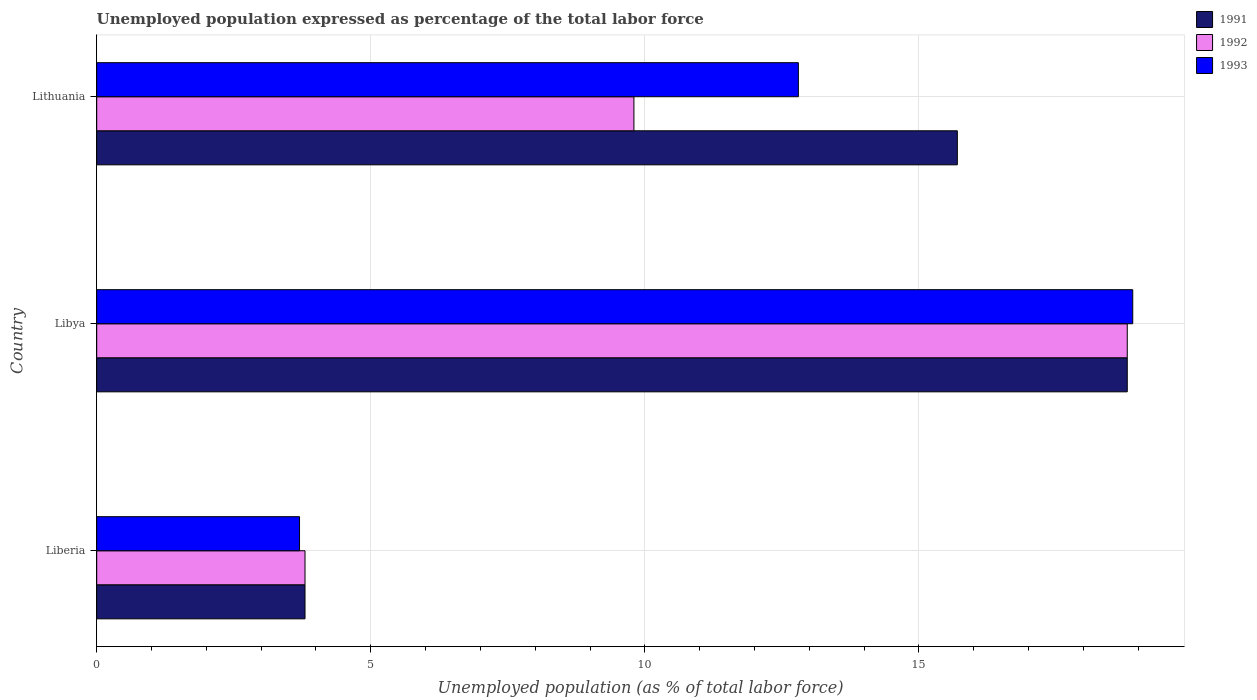How many different coloured bars are there?
Your answer should be compact. 3. Are the number of bars on each tick of the Y-axis equal?
Your response must be concise. Yes. What is the label of the 3rd group of bars from the top?
Your response must be concise. Liberia. What is the unemployment in in 1993 in Libya?
Provide a succinct answer. 18.9. Across all countries, what is the maximum unemployment in in 1991?
Your answer should be compact. 18.8. Across all countries, what is the minimum unemployment in in 1993?
Offer a terse response. 3.7. In which country was the unemployment in in 1993 maximum?
Your response must be concise. Libya. In which country was the unemployment in in 1993 minimum?
Give a very brief answer. Liberia. What is the total unemployment in in 1991 in the graph?
Your answer should be compact. 38.3. What is the difference between the unemployment in in 1993 in Liberia and that in Libya?
Offer a very short reply. -15.2. What is the difference between the unemployment in in 1991 in Lithuania and the unemployment in in 1992 in Libya?
Make the answer very short. -3.1. What is the average unemployment in in 1992 per country?
Your response must be concise. 10.8. In how many countries, is the unemployment in in 1992 greater than 14 %?
Your answer should be compact. 1. What is the ratio of the unemployment in in 1992 in Liberia to that in Libya?
Your answer should be compact. 0.2. Is the difference between the unemployment in in 1991 in Libya and Lithuania greater than the difference between the unemployment in in 1992 in Libya and Lithuania?
Your answer should be compact. No. What is the difference between the highest and the second highest unemployment in in 1993?
Keep it short and to the point. 6.1. What is the difference between the highest and the lowest unemployment in in 1991?
Your response must be concise. 15. What does the 3rd bar from the top in Lithuania represents?
Give a very brief answer. 1991. Does the graph contain any zero values?
Provide a short and direct response. No. How many legend labels are there?
Make the answer very short. 3. How are the legend labels stacked?
Offer a terse response. Vertical. What is the title of the graph?
Provide a succinct answer. Unemployed population expressed as percentage of the total labor force. What is the label or title of the X-axis?
Provide a succinct answer. Unemployed population (as % of total labor force). What is the Unemployed population (as % of total labor force) in 1991 in Liberia?
Keep it short and to the point. 3.8. What is the Unemployed population (as % of total labor force) in 1992 in Liberia?
Offer a very short reply. 3.8. What is the Unemployed population (as % of total labor force) in 1993 in Liberia?
Ensure brevity in your answer.  3.7. What is the Unemployed population (as % of total labor force) of 1991 in Libya?
Your answer should be very brief. 18.8. What is the Unemployed population (as % of total labor force) in 1992 in Libya?
Keep it short and to the point. 18.8. What is the Unemployed population (as % of total labor force) of 1993 in Libya?
Offer a very short reply. 18.9. What is the Unemployed population (as % of total labor force) in 1991 in Lithuania?
Your answer should be very brief. 15.7. What is the Unemployed population (as % of total labor force) in 1992 in Lithuania?
Keep it short and to the point. 9.8. What is the Unemployed population (as % of total labor force) in 1993 in Lithuania?
Offer a very short reply. 12.8. Across all countries, what is the maximum Unemployed population (as % of total labor force) in 1991?
Keep it short and to the point. 18.8. Across all countries, what is the maximum Unemployed population (as % of total labor force) in 1992?
Your answer should be very brief. 18.8. Across all countries, what is the maximum Unemployed population (as % of total labor force) in 1993?
Your answer should be compact. 18.9. Across all countries, what is the minimum Unemployed population (as % of total labor force) in 1991?
Ensure brevity in your answer.  3.8. Across all countries, what is the minimum Unemployed population (as % of total labor force) of 1992?
Your answer should be very brief. 3.8. Across all countries, what is the minimum Unemployed population (as % of total labor force) of 1993?
Keep it short and to the point. 3.7. What is the total Unemployed population (as % of total labor force) in 1991 in the graph?
Your answer should be compact. 38.3. What is the total Unemployed population (as % of total labor force) in 1992 in the graph?
Make the answer very short. 32.4. What is the total Unemployed population (as % of total labor force) of 1993 in the graph?
Provide a succinct answer. 35.4. What is the difference between the Unemployed population (as % of total labor force) of 1992 in Liberia and that in Libya?
Your response must be concise. -15. What is the difference between the Unemployed population (as % of total labor force) of 1993 in Liberia and that in Libya?
Your answer should be very brief. -15.2. What is the difference between the Unemployed population (as % of total labor force) in 1991 in Liberia and that in Lithuania?
Provide a short and direct response. -11.9. What is the difference between the Unemployed population (as % of total labor force) in 1992 in Liberia and that in Lithuania?
Your answer should be compact. -6. What is the difference between the Unemployed population (as % of total labor force) in 1993 in Liberia and that in Lithuania?
Make the answer very short. -9.1. What is the difference between the Unemployed population (as % of total labor force) of 1991 in Libya and that in Lithuania?
Your answer should be compact. 3.1. What is the difference between the Unemployed population (as % of total labor force) of 1993 in Libya and that in Lithuania?
Your answer should be very brief. 6.1. What is the difference between the Unemployed population (as % of total labor force) of 1991 in Liberia and the Unemployed population (as % of total labor force) of 1993 in Libya?
Your answer should be compact. -15.1. What is the difference between the Unemployed population (as % of total labor force) in 1992 in Liberia and the Unemployed population (as % of total labor force) in 1993 in Libya?
Offer a terse response. -15.1. What is the difference between the Unemployed population (as % of total labor force) in 1991 in Liberia and the Unemployed population (as % of total labor force) in 1992 in Lithuania?
Offer a terse response. -6. What is the difference between the Unemployed population (as % of total labor force) of 1991 in Liberia and the Unemployed population (as % of total labor force) of 1993 in Lithuania?
Offer a very short reply. -9. What is the difference between the Unemployed population (as % of total labor force) of 1991 in Libya and the Unemployed population (as % of total labor force) of 1992 in Lithuania?
Give a very brief answer. 9. What is the difference between the Unemployed population (as % of total labor force) in 1991 in Libya and the Unemployed population (as % of total labor force) in 1993 in Lithuania?
Ensure brevity in your answer.  6. What is the average Unemployed population (as % of total labor force) in 1991 per country?
Ensure brevity in your answer.  12.77. What is the average Unemployed population (as % of total labor force) of 1992 per country?
Ensure brevity in your answer.  10.8. What is the difference between the Unemployed population (as % of total labor force) in 1992 and Unemployed population (as % of total labor force) in 1993 in Liberia?
Provide a short and direct response. 0.1. What is the difference between the Unemployed population (as % of total labor force) of 1991 and Unemployed population (as % of total labor force) of 1993 in Libya?
Ensure brevity in your answer.  -0.1. What is the difference between the Unemployed population (as % of total labor force) in 1992 and Unemployed population (as % of total labor force) in 1993 in Libya?
Make the answer very short. -0.1. What is the difference between the Unemployed population (as % of total labor force) in 1991 and Unemployed population (as % of total labor force) in 1993 in Lithuania?
Your answer should be very brief. 2.9. What is the difference between the Unemployed population (as % of total labor force) of 1992 and Unemployed population (as % of total labor force) of 1993 in Lithuania?
Give a very brief answer. -3. What is the ratio of the Unemployed population (as % of total labor force) in 1991 in Liberia to that in Libya?
Provide a succinct answer. 0.2. What is the ratio of the Unemployed population (as % of total labor force) of 1992 in Liberia to that in Libya?
Your response must be concise. 0.2. What is the ratio of the Unemployed population (as % of total labor force) of 1993 in Liberia to that in Libya?
Your response must be concise. 0.2. What is the ratio of the Unemployed population (as % of total labor force) of 1991 in Liberia to that in Lithuania?
Provide a short and direct response. 0.24. What is the ratio of the Unemployed population (as % of total labor force) in 1992 in Liberia to that in Lithuania?
Your response must be concise. 0.39. What is the ratio of the Unemployed population (as % of total labor force) in 1993 in Liberia to that in Lithuania?
Make the answer very short. 0.29. What is the ratio of the Unemployed population (as % of total labor force) in 1991 in Libya to that in Lithuania?
Your response must be concise. 1.2. What is the ratio of the Unemployed population (as % of total labor force) in 1992 in Libya to that in Lithuania?
Offer a terse response. 1.92. What is the ratio of the Unemployed population (as % of total labor force) in 1993 in Libya to that in Lithuania?
Give a very brief answer. 1.48. What is the difference between the highest and the second highest Unemployed population (as % of total labor force) of 1993?
Your answer should be very brief. 6.1. What is the difference between the highest and the lowest Unemployed population (as % of total labor force) of 1991?
Provide a succinct answer. 15. 